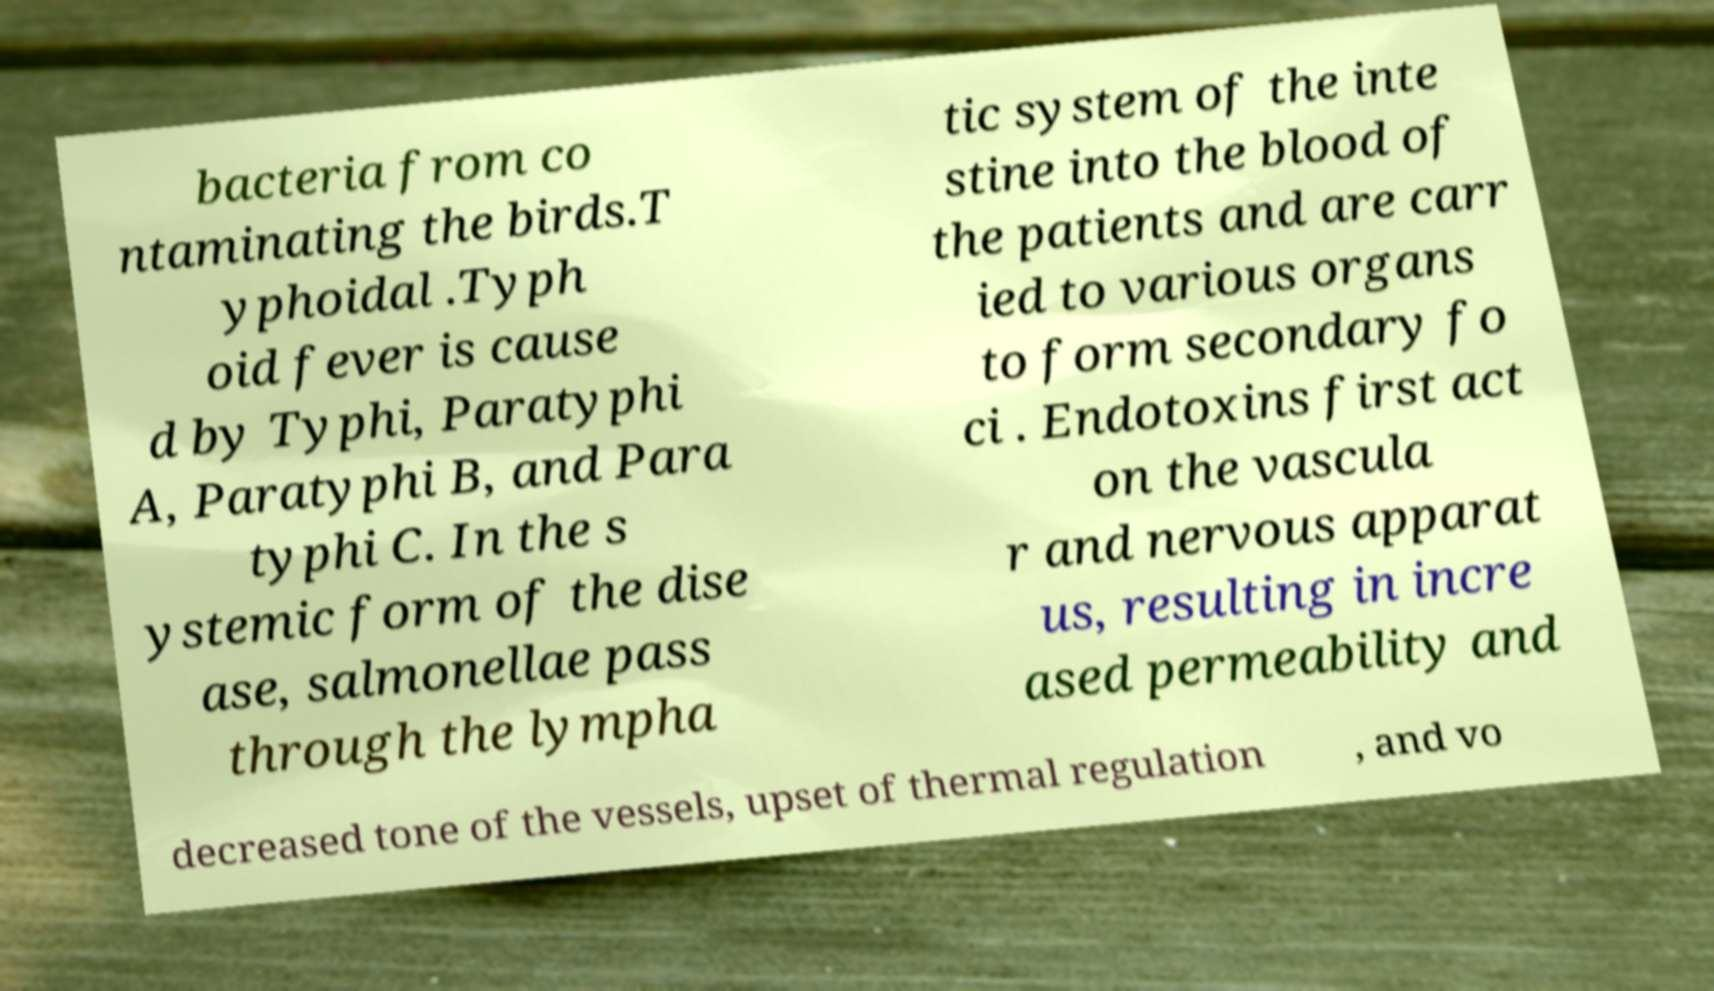Can you accurately transcribe the text from the provided image for me? bacteria from co ntaminating the birds.T yphoidal .Typh oid fever is cause d by Typhi, Paratyphi A, Paratyphi B, and Para typhi C. In the s ystemic form of the dise ase, salmonellae pass through the lympha tic system of the inte stine into the blood of the patients and are carr ied to various organs to form secondary fo ci . Endotoxins first act on the vascula r and nervous apparat us, resulting in incre ased permeability and decreased tone of the vessels, upset of thermal regulation , and vo 